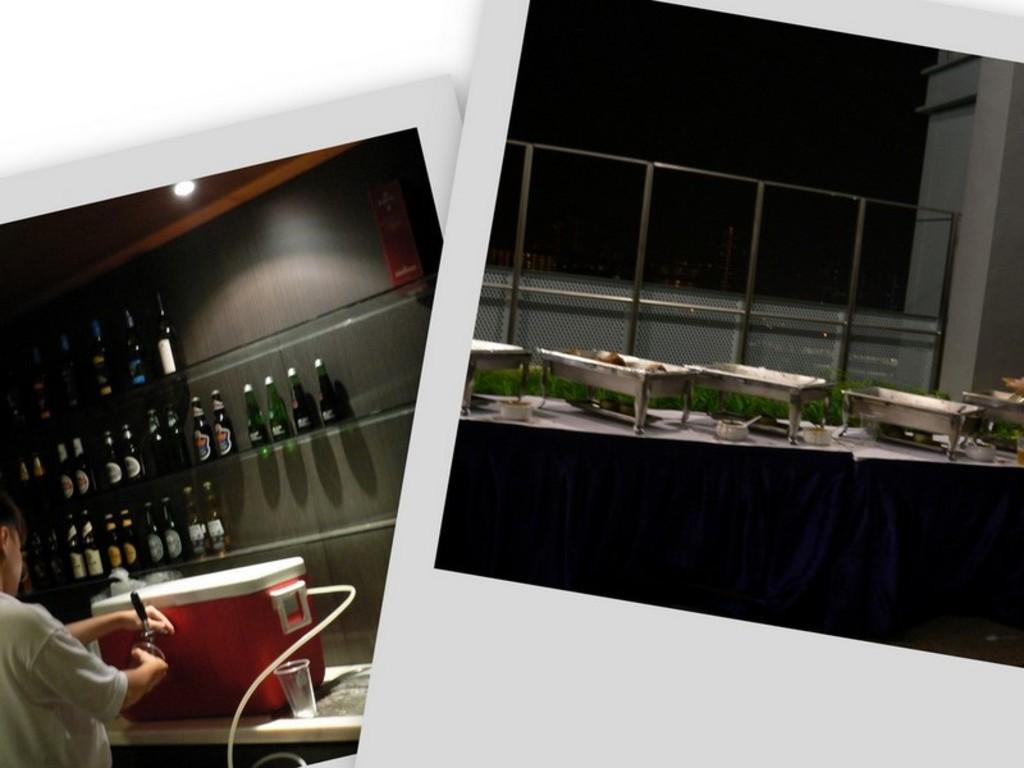Please provide a concise description of this image. This image is a collage picture. In this image we can see collage pictures of bottles and food items placed in dishes. 